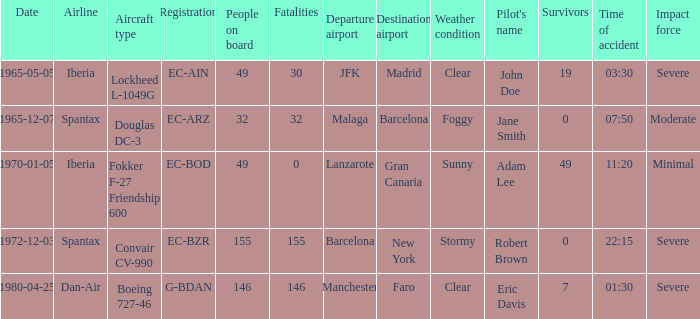What is the number of people on board at Iberia Airline, with the aircraft type of lockheed l-1049g? 49.0. 